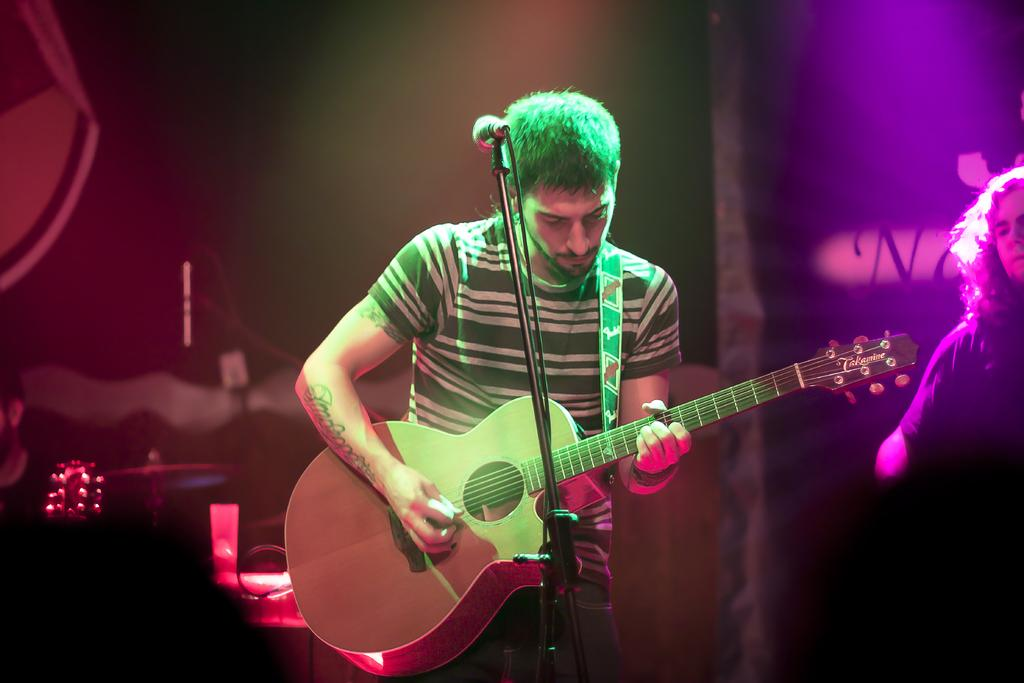What is the man in the image doing? The man is playing a guitar in the image. What is the man wearing in the image? The man is wearing a t-shirt in the image. What is the position of the man in the image? The man is standing in the image. What object is in front of the man in the image? There is a microphone stand in front of the man in the image. Can you describe the other person in the image? There is another person on the right side of the image. What type of copper material is used to make the guitar in the image? There is no mention of copper or any specific material used to make the guitar in the image. The guitar's material cannot be determined from the provided facts. What arm is the man using to play the guitar in the image? The image does not show the man's arms or which arm he is using to play the guitar. This information cannot be determined from the provided facts. 